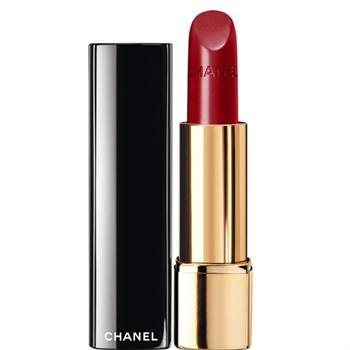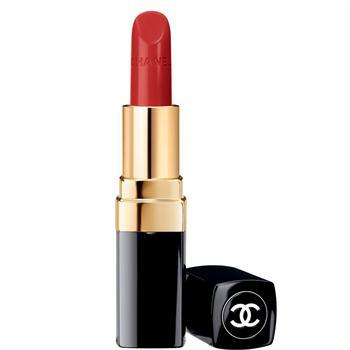The first image is the image on the left, the second image is the image on the right. For the images shown, is this caption "There are at most 2 lipsticks in the image pair" true? Answer yes or no. Yes. 